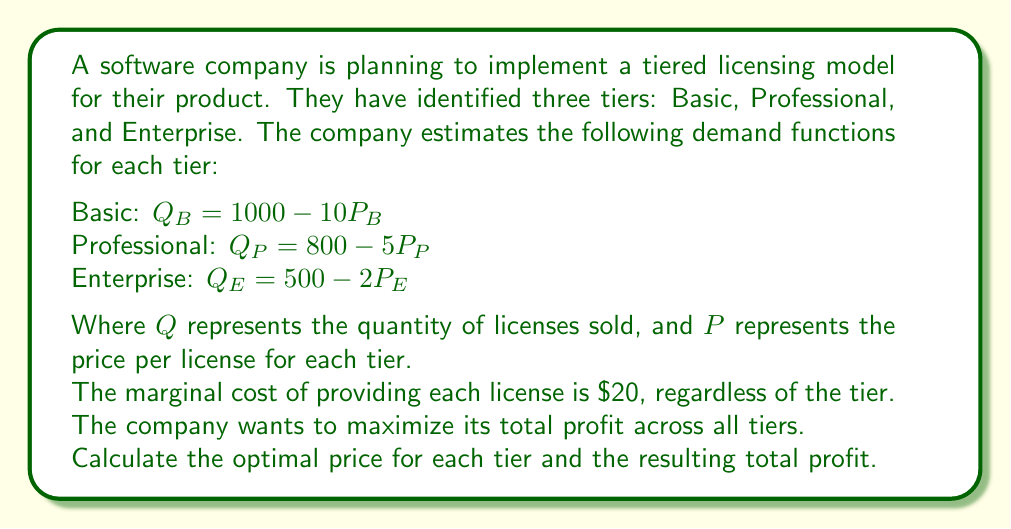Could you help me with this problem? To solve this problem, we'll follow these steps:

1. Set up the profit function for each tier
2. Find the optimal price for each tier using differentiation
3. Calculate the quantity sold at optimal prices
4. Compute the total profit

Step 1: Set up the profit functions

For each tier, the profit function is:
$\text{Profit} = \text{Revenue} - \text{Cost} = PQ - 20Q = Q(P - 20)$

Basic: $\pi_B = (P_B - 20)(1000 - 10P_B)$
Professional: $\pi_P = (P_P - 20)(800 - 5P_P)$
Enterprise: $\pi_E = (P_E - 20)(500 - 2P_E)$

Step 2: Find optimal prices

To maximize profit, we differentiate each profit function with respect to price and set it to zero:

Basic:
$$\frac{d\pi_B}{dP_B} = 1000 - 20P_B = 0$$
$$P_B^* = 50$$

Professional:
$$\frac{d\pi_P}{dP_P} = 800 - 10P_P = 0$$
$$P_P^* = 80$$

Enterprise:
$$\frac{d\pi_E}{dP_E} = 500 - 4P_E = 0$$
$$P_E^* = 125$$

Step 3: Calculate quantities sold

Basic: $Q_B = 1000 - 10(50) = 500$
Professional: $Q_P = 800 - 5(80) = 400$
Enterprise: $Q_E = 500 - 2(125) = 250$

Step 4: Compute total profit

Basic: $\pi_B = (50 - 20)(500) = 15,000$
Professional: $\pi_P = (80 - 20)(400) = 24,000$
Enterprise: $\pi_E = (125 - 20)(250) = 26,250$

Total profit: $15,000 + 24,000 + 26,250 = 65,250$
Answer: The optimal prices for each tier are:
Basic: $50
Professional: $80
Enterprise: $125

The resulting total profit is $65,250. 